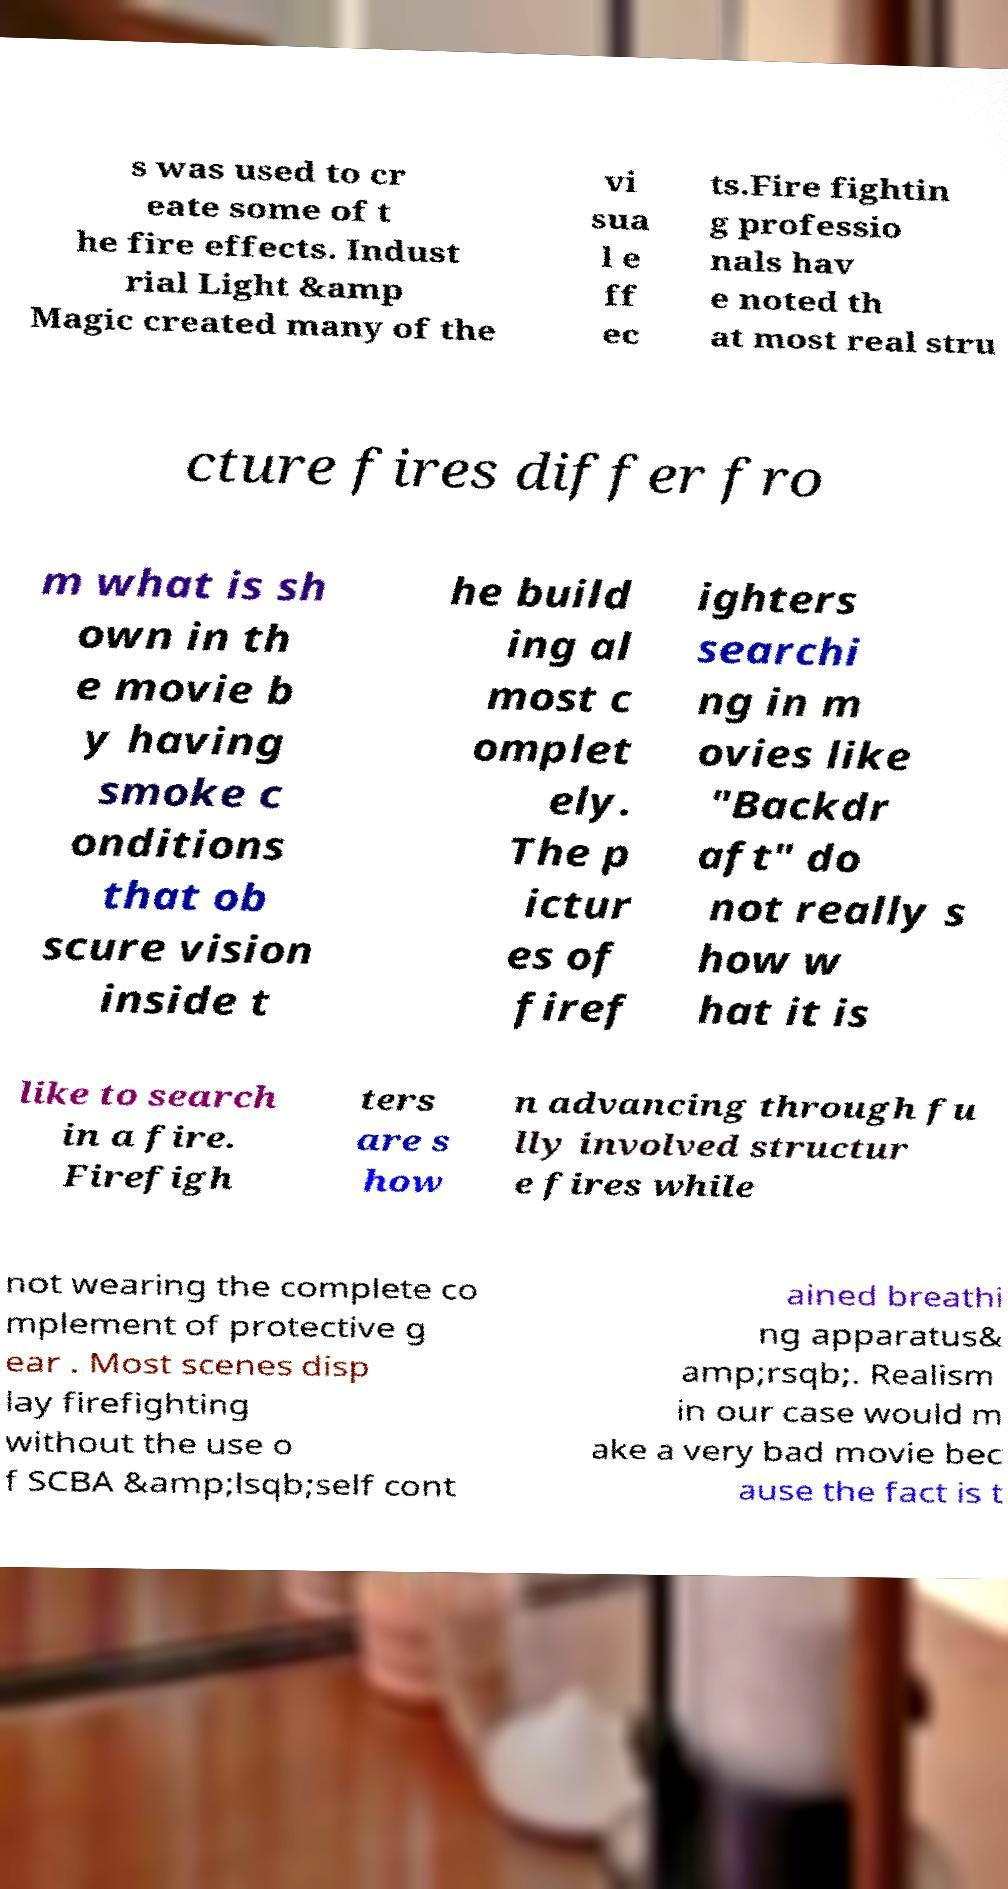Please identify and transcribe the text found in this image. s was used to cr eate some of t he fire effects. Indust rial Light &amp Magic created many of the vi sua l e ff ec ts.Fire fightin g professio nals hav e noted th at most real stru cture fires differ fro m what is sh own in th e movie b y having smoke c onditions that ob scure vision inside t he build ing al most c omplet ely. The p ictur es of firef ighters searchi ng in m ovies like "Backdr aft" do not really s how w hat it is like to search in a fire. Firefigh ters are s how n advancing through fu lly involved structur e fires while not wearing the complete co mplement of protective g ear . Most scenes disp lay firefighting without the use o f SCBA &amp;lsqb;self cont ained breathi ng apparatus& amp;rsqb;. Realism in our case would m ake a very bad movie bec ause the fact is t 